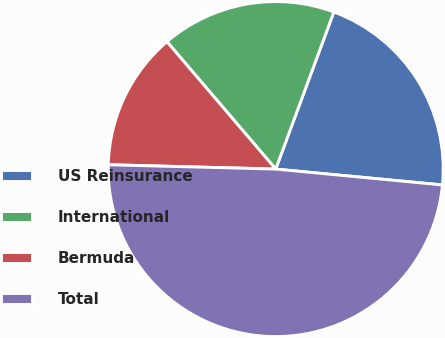Convert chart to OTSL. <chart><loc_0><loc_0><loc_500><loc_500><pie_chart><fcel>US Reinsurance<fcel>International<fcel>Bermuda<fcel>Total<nl><fcel>20.87%<fcel>16.89%<fcel>13.34%<fcel>48.9%<nl></chart> 